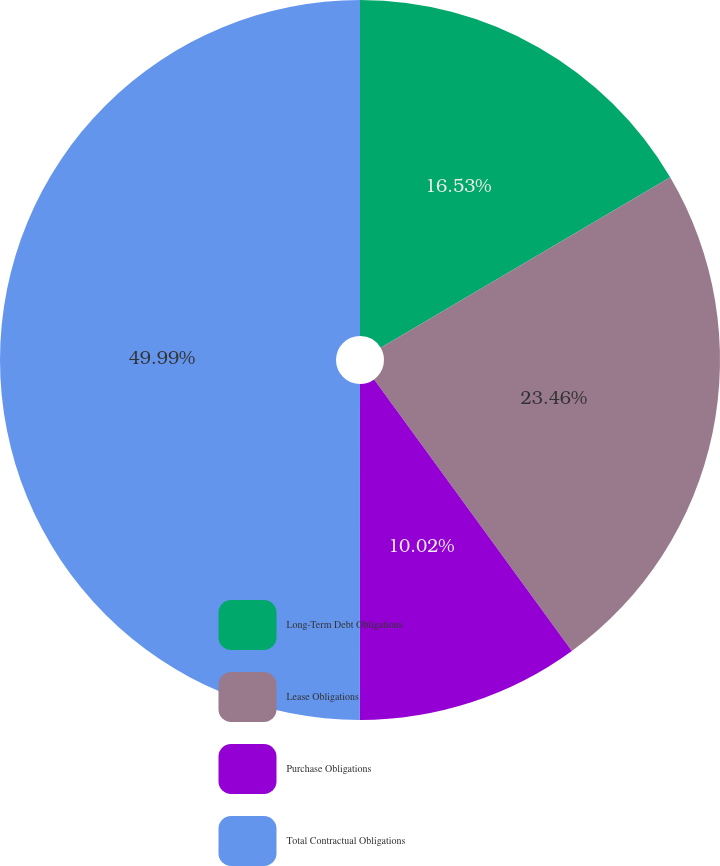<chart> <loc_0><loc_0><loc_500><loc_500><pie_chart><fcel>Long-Term Debt Obligations<fcel>Lease Obligations<fcel>Purchase Obligations<fcel>Total Contractual Obligations<nl><fcel>16.53%<fcel>23.46%<fcel>10.02%<fcel>50.0%<nl></chart> 